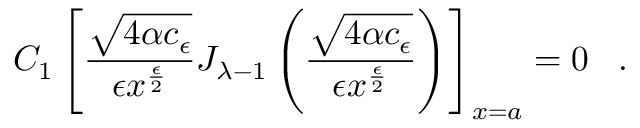Convert formula to latex. <formula><loc_0><loc_0><loc_500><loc_500>C _ { 1 } \left [ \frac { \sqrt { 4 \alpha c _ { \epsilon } } } { \epsilon x ^ { \frac { \epsilon } { 2 } } } J _ { { \lambda } - 1 } \left ( \frac { \sqrt { 4 \alpha c _ { \epsilon } } } { \epsilon x ^ { \frac { \epsilon } { 2 } } } \right ) \right ] _ { x = a } = 0 \, .</formula> 